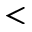<formula> <loc_0><loc_0><loc_500><loc_500><</formula> 